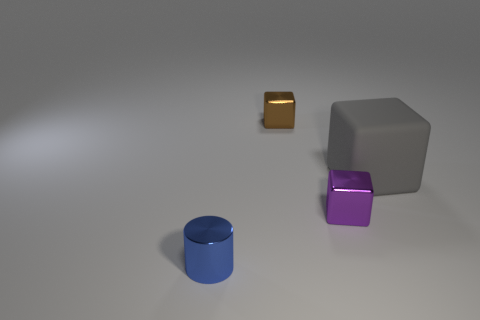Is there a tiny cylinder that is in front of the large gray block that is on the right side of the tiny block to the right of the brown object?
Your answer should be compact. Yes. How many objects are either small metallic cubes or brown objects?
Offer a very short reply. 2. Does the big gray cube have the same material as the small object that is behind the purple shiny block?
Give a very brief answer. No. What number of things are tiny metal objects that are on the left side of the brown cube or things that are behind the purple object?
Offer a terse response. 3. There is a object that is left of the purple object and behind the tiny purple cube; what shape is it?
Make the answer very short. Cube. What number of small objects are behind the small cube behind the large gray matte object?
Keep it short and to the point. 0. Is there anything else that has the same material as the big block?
Your response must be concise. No. How many objects are either small things behind the gray matte cube or tiny cylinders?
Offer a very short reply. 2. There is a object that is behind the big thing; what is its size?
Ensure brevity in your answer.  Small. What material is the brown cube?
Keep it short and to the point. Metal. 